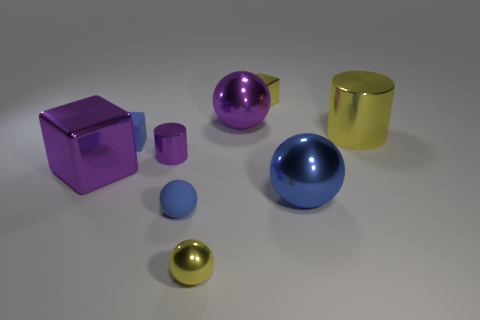What number of large things are either purple metal things or blue rubber spheres? There are two large items that meet the criteria: one large purple metal cube and one large blue rubber sphere. 